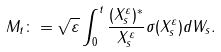Convert formula to latex. <formula><loc_0><loc_0><loc_500><loc_500>M _ { t } \colon = \sqrt { \varepsilon } \int _ { 0 } ^ { t } \frac { ( X ^ { \varepsilon } _ { s } ) ^ { * } } { \| X ^ { \varepsilon } _ { s } \| } \sigma ( X ^ { \varepsilon } _ { s } ) d W _ { s } .</formula> 